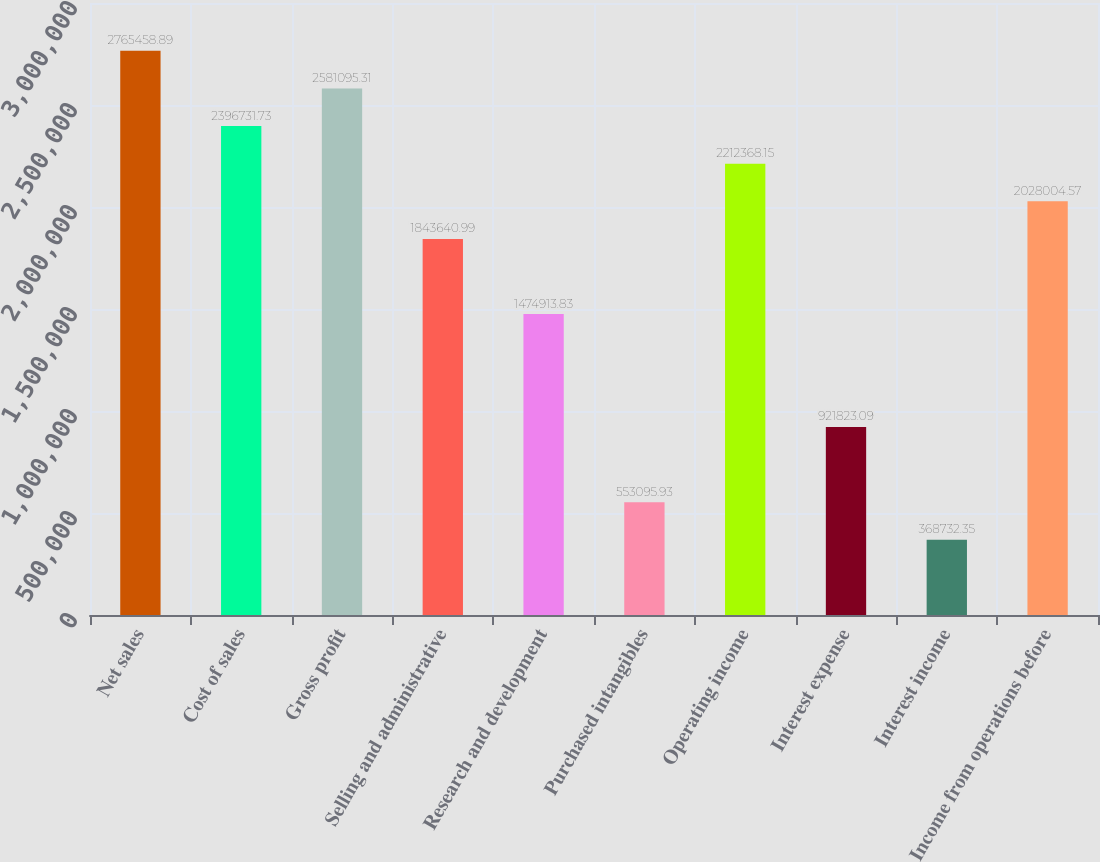Convert chart to OTSL. <chart><loc_0><loc_0><loc_500><loc_500><bar_chart><fcel>Net sales<fcel>Cost of sales<fcel>Gross profit<fcel>Selling and administrative<fcel>Research and development<fcel>Purchased intangibles<fcel>Operating income<fcel>Interest expense<fcel>Interest income<fcel>Income from operations before<nl><fcel>2.76546e+06<fcel>2.39673e+06<fcel>2.5811e+06<fcel>1.84364e+06<fcel>1.47491e+06<fcel>553096<fcel>2.21237e+06<fcel>921823<fcel>368732<fcel>2.028e+06<nl></chart> 